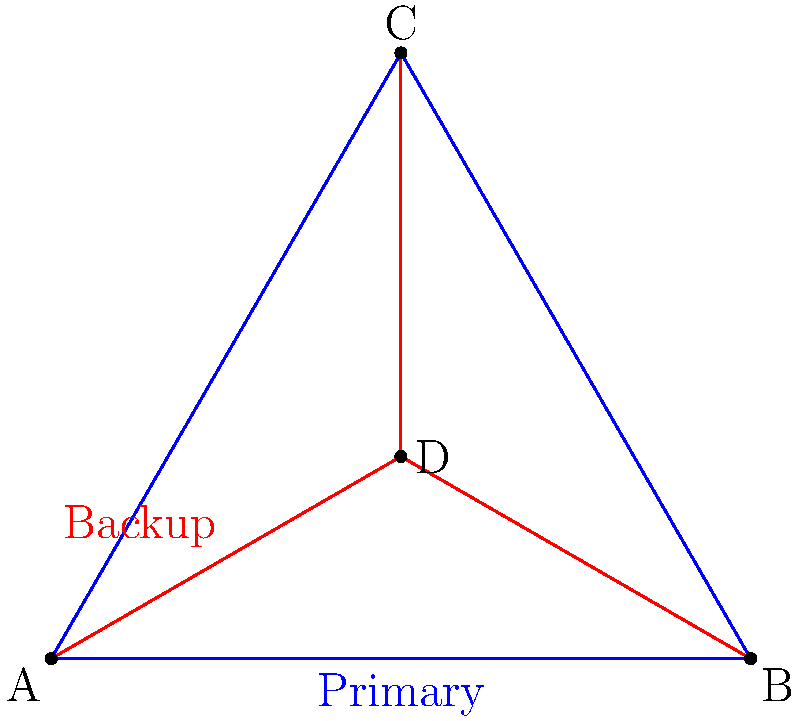In your manufacturing network, you have implemented a redundant infrastructure as shown in the diagram. Nodes A, B, and C represent critical manufacturing processes, while node D is a central hub. The blue lines represent the primary connections, and the red lines represent backup connections. If the primary connection between A and B fails, what is the maximum number of hops required for data to travel from A to B using the backup routes? To determine the maximum number of hops required for data to travel from A to B using backup routes when the primary connection fails, let's follow these steps:

1. Identify the available backup routes:
   - A → D → B
   - A → D → C → B

2. Count the hops for each route:
   - A → D → B: 2 hops
   - A → D → C → B: 3 hops

3. Compare the number of hops:
   - The route A → D → B has 2 hops
   - The route A → D → C → B has 3 hops

4. Determine the maximum:
   - The maximum number of hops is 3, which occurs when data travels through A → D → C → B

Therefore, in the worst-case scenario, data will need to travel through a maximum of 3 hops to reach B from A using the backup routes when the primary connection fails.
Answer: 3 hops 